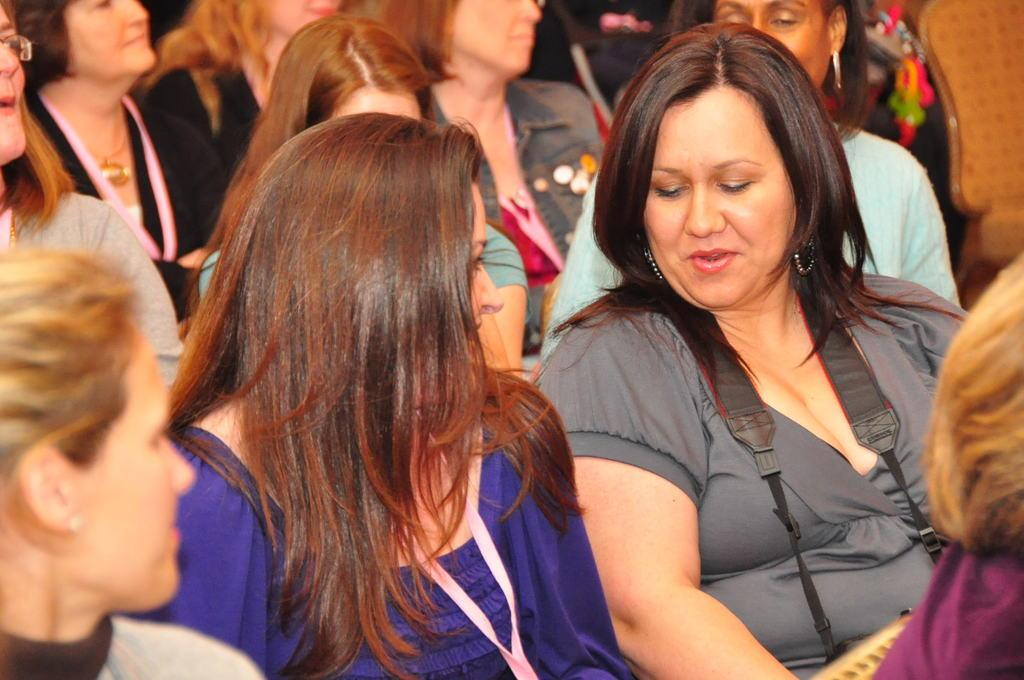What are the women in the image doing? The women are sitting in the chair and discussing something. What is the facial expression of the women in the image? The women are smiling. Are there any other women present in the image? Yes, there are other women sitting behind them. What type of trees can be seen in the image? There are no trees present in the image; it features women sitting in chairs and discussing something. 